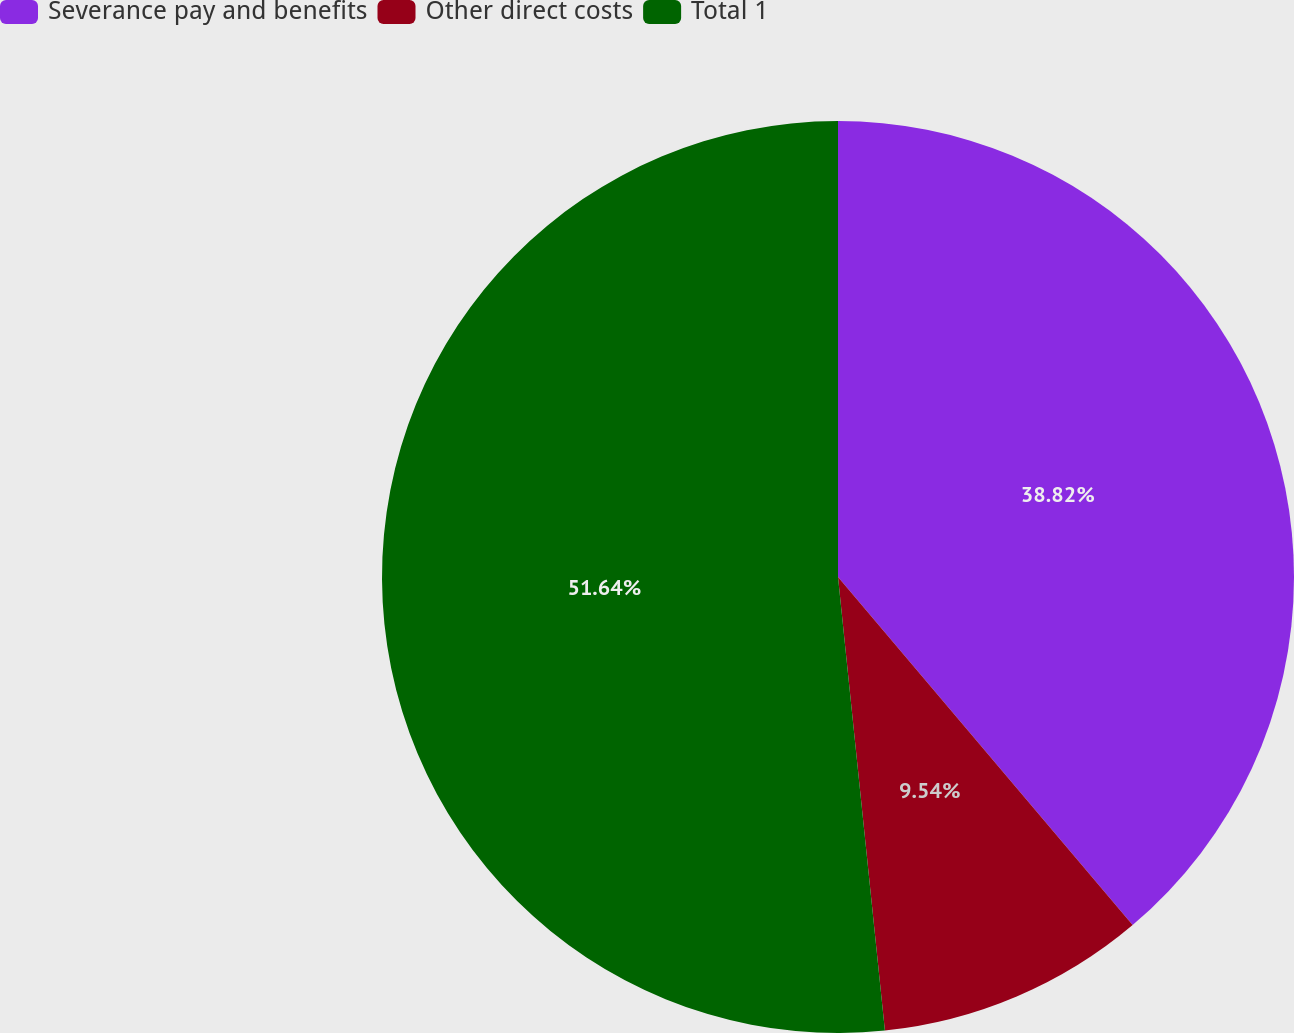Convert chart. <chart><loc_0><loc_0><loc_500><loc_500><pie_chart><fcel>Severance pay and benefits<fcel>Other direct costs<fcel>Total 1<nl><fcel>38.82%<fcel>9.54%<fcel>51.64%<nl></chart> 